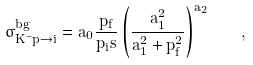<formula> <loc_0><loc_0><loc_500><loc_500>\sigma ^ { b g } _ { K ^ { - } p \to i } = a _ { 0 } \frac { p _ { f } } { p _ { i } s } \left ( \frac { a _ { 1 } ^ { 2 } } { a _ { 1 } ^ { 2 } + p _ { f } ^ { 2 } } \right ) ^ { a _ { 2 } } \quad ,</formula> 